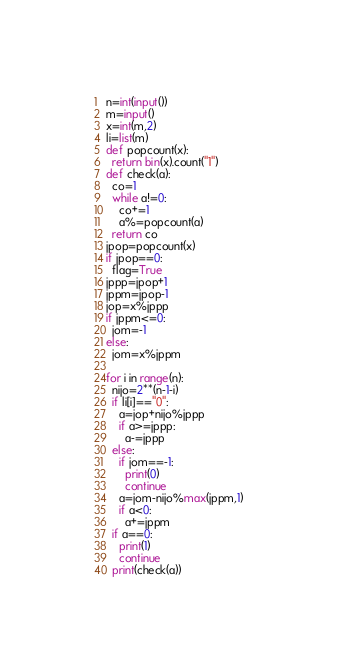<code> <loc_0><loc_0><loc_500><loc_500><_Python_>n=int(input())
m=input()
x=int(m,2)
li=list(m)
def popcount(x):
  return bin(x).count("1")
def check(a):
  co=1
  while a!=0:
    co+=1
    a%=popcount(a)
  return co
jpop=popcount(x)
if jpop==0:
  flag=True
jppp=jpop+1
jppm=jpop-1
jop=x%jppp
if jppm<=0:
  jom=-1
else:
  jom=x%jppm

for i in range(n):
  nijo=2**(n-1-i)
  if li[i]=="0":
    a=jop+nijo%jppp
    if a>=jppp:
      a-=jppp
  else:
    if jom==-1:
      print(0)
      continue
    a=jom-nijo%max(jppm,1)
    if a<0:
      a+=jppm
  if a==0:
    print(1)
    continue
  print(check(a))</code> 